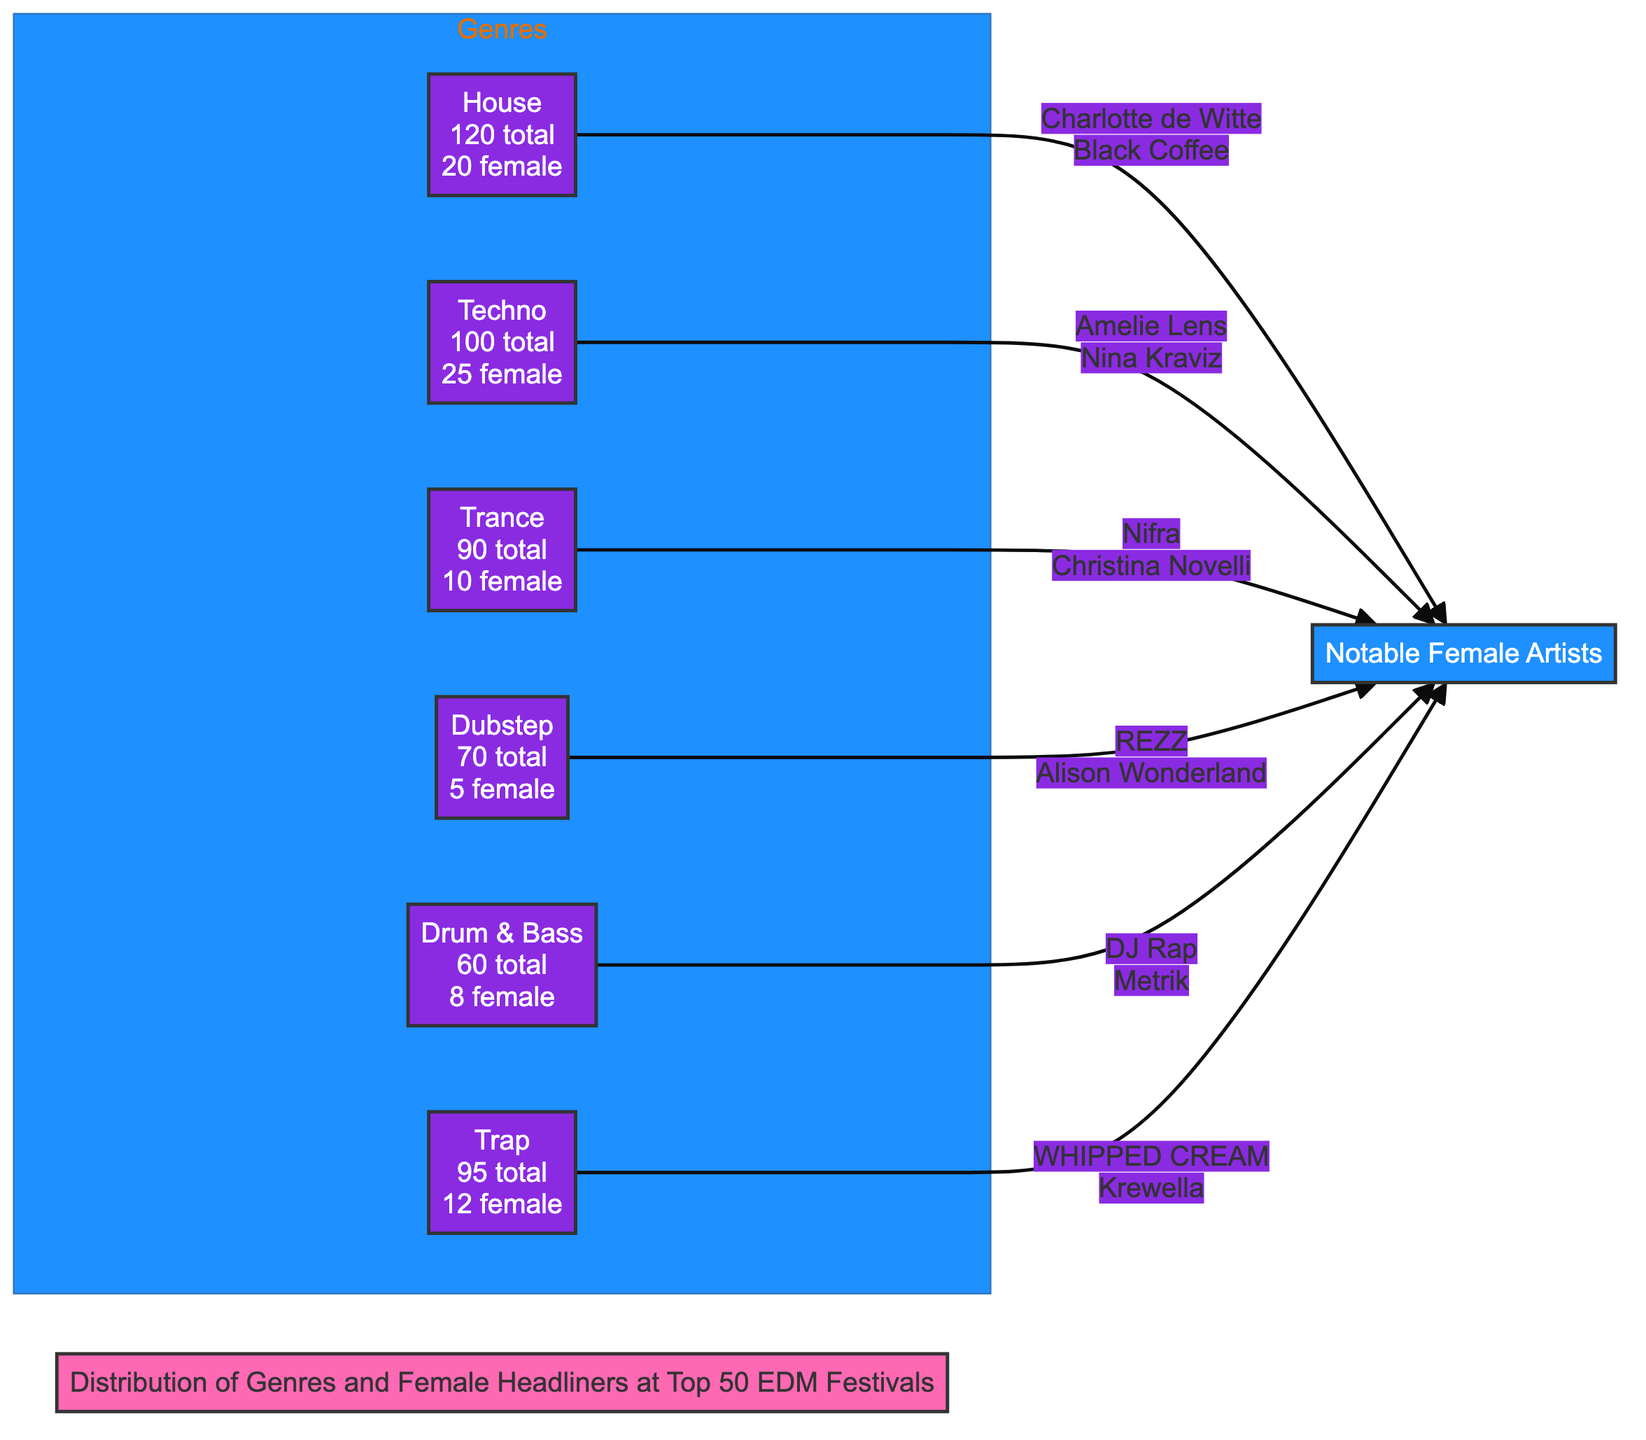What is the total number of genres depicted in the diagram? The diagram categorizes the genres into different groups, specifically listing House, Techno, Trance, Dubstep, Drum & Bass, and Trap. By counting each of these, we can determine that there are a total of 6 genres represented in the diagram.
Answer: 6 Which genre has the highest number of female headliners? By reviewing the information provided for female headliners in each genre, Techno has 25 female headliners, which is the highest compared to House with 20, Trance with 10, Dubstep with 5, Drum & Bass with 8, and Trap with 12. Thus, Techno is the genre with the highest number of female headliners.
Answer: Techno What is the total number of female headliners across all genres? Adding up the number of female headliners from each genre: 20 (House) + 25 (Techno) + 10 (Trance) + 5 (Dubstep) + 8 (Drum & Bass) + 12 (Trap) gives a total of 70 female headliners in all genres represented in the diagram.
Answer: 70 Which genre has the lowest number of total acts? Reviewing the total act counts for each genre: House (120), Techno (100), Trance (90), Dubstep (70), Drum & Bass (60), and Trap (95), we find that Drum & Bass has the lowest total at 60 acts.
Answer: Drum & Bass How many female headliners are in Dubstep? The diagram shows that the Dubstep genre has 5 female headliners indicated next to it. No additional calculations or reasoning are needed, as this is a specific value stated within the genre's section.
Answer: 5 Which notable female artist is associated with House? The diagram clearly lists Charlotte de Witte and Black Coffee as notable female artists associated with the House genre. Since we are looking for just one, we can choose either of the names; however, Charlotte de Witte is often highlighted in discussions.
Answer: Charlotte de Witte 